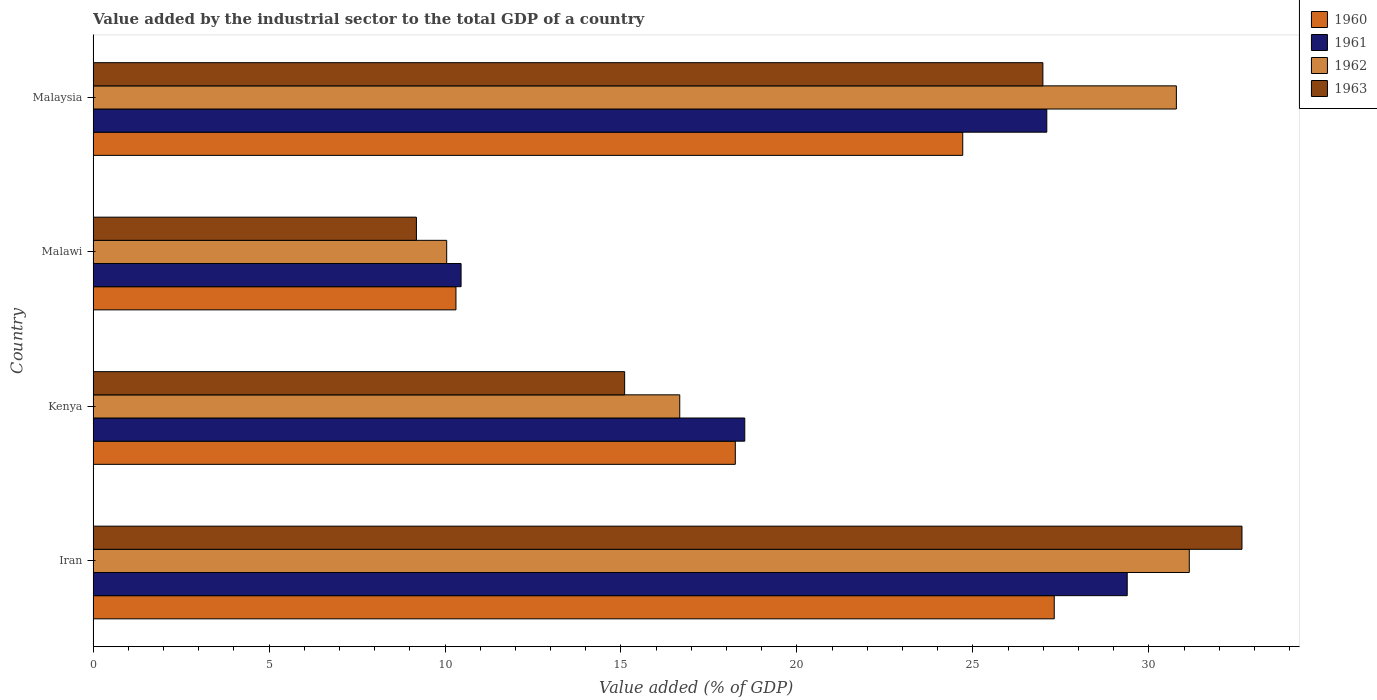How many groups of bars are there?
Provide a short and direct response. 4. Are the number of bars per tick equal to the number of legend labels?
Your response must be concise. Yes. How many bars are there on the 2nd tick from the top?
Give a very brief answer. 4. How many bars are there on the 3rd tick from the bottom?
Ensure brevity in your answer.  4. What is the label of the 2nd group of bars from the top?
Keep it short and to the point. Malawi. What is the value added by the industrial sector to the total GDP in 1963 in Kenya?
Offer a very short reply. 15.1. Across all countries, what is the maximum value added by the industrial sector to the total GDP in 1961?
Keep it short and to the point. 29.38. Across all countries, what is the minimum value added by the industrial sector to the total GDP in 1960?
Make the answer very short. 10.31. In which country was the value added by the industrial sector to the total GDP in 1961 maximum?
Your answer should be compact. Iran. In which country was the value added by the industrial sector to the total GDP in 1961 minimum?
Offer a very short reply. Malawi. What is the total value added by the industrial sector to the total GDP in 1962 in the graph?
Your response must be concise. 88.65. What is the difference between the value added by the industrial sector to the total GDP in 1961 in Iran and that in Malaysia?
Your answer should be very brief. 2.29. What is the difference between the value added by the industrial sector to the total GDP in 1961 in Malaysia and the value added by the industrial sector to the total GDP in 1960 in Malawi?
Offer a terse response. 16.79. What is the average value added by the industrial sector to the total GDP in 1962 per country?
Keep it short and to the point. 22.16. What is the difference between the value added by the industrial sector to the total GDP in 1961 and value added by the industrial sector to the total GDP in 1962 in Kenya?
Give a very brief answer. 1.85. What is the ratio of the value added by the industrial sector to the total GDP in 1963 in Malawi to that in Malaysia?
Offer a terse response. 0.34. Is the value added by the industrial sector to the total GDP in 1962 in Iran less than that in Malawi?
Give a very brief answer. No. Is the difference between the value added by the industrial sector to the total GDP in 1961 in Iran and Kenya greater than the difference between the value added by the industrial sector to the total GDP in 1962 in Iran and Kenya?
Provide a short and direct response. No. What is the difference between the highest and the second highest value added by the industrial sector to the total GDP in 1960?
Provide a short and direct response. 2.6. What is the difference between the highest and the lowest value added by the industrial sector to the total GDP in 1963?
Provide a succinct answer. 23.46. Is the sum of the value added by the industrial sector to the total GDP in 1961 in Iran and Malawi greater than the maximum value added by the industrial sector to the total GDP in 1963 across all countries?
Provide a short and direct response. Yes. What does the 2nd bar from the top in Kenya represents?
Your answer should be very brief. 1962. What does the 2nd bar from the bottom in Malawi represents?
Give a very brief answer. 1961. Is it the case that in every country, the sum of the value added by the industrial sector to the total GDP in 1961 and value added by the industrial sector to the total GDP in 1963 is greater than the value added by the industrial sector to the total GDP in 1960?
Offer a very short reply. Yes. How many bars are there?
Ensure brevity in your answer.  16. Are all the bars in the graph horizontal?
Provide a succinct answer. Yes. How many countries are there in the graph?
Provide a succinct answer. 4. What is the difference between two consecutive major ticks on the X-axis?
Ensure brevity in your answer.  5. Are the values on the major ticks of X-axis written in scientific E-notation?
Make the answer very short. No. Where does the legend appear in the graph?
Your answer should be compact. Top right. What is the title of the graph?
Make the answer very short. Value added by the industrial sector to the total GDP of a country. Does "2008" appear as one of the legend labels in the graph?
Make the answer very short. No. What is the label or title of the X-axis?
Provide a succinct answer. Value added (% of GDP). What is the label or title of the Y-axis?
Offer a terse response. Country. What is the Value added (% of GDP) of 1960 in Iran?
Provide a succinct answer. 27.31. What is the Value added (% of GDP) in 1961 in Iran?
Give a very brief answer. 29.38. What is the Value added (% of GDP) in 1962 in Iran?
Make the answer very short. 31.15. What is the Value added (% of GDP) of 1963 in Iran?
Offer a terse response. 32.65. What is the Value added (% of GDP) of 1960 in Kenya?
Provide a succinct answer. 18.25. What is the Value added (% of GDP) of 1961 in Kenya?
Provide a short and direct response. 18.52. What is the Value added (% of GDP) in 1962 in Kenya?
Your answer should be very brief. 16.67. What is the Value added (% of GDP) in 1963 in Kenya?
Your answer should be very brief. 15.1. What is the Value added (% of GDP) of 1960 in Malawi?
Ensure brevity in your answer.  10.31. What is the Value added (% of GDP) of 1961 in Malawi?
Make the answer very short. 10.46. What is the Value added (% of GDP) of 1962 in Malawi?
Provide a short and direct response. 10.05. What is the Value added (% of GDP) of 1963 in Malawi?
Provide a short and direct response. 9.19. What is the Value added (% of GDP) in 1960 in Malaysia?
Your answer should be very brief. 24.71. What is the Value added (% of GDP) of 1961 in Malaysia?
Your response must be concise. 27.1. What is the Value added (% of GDP) in 1962 in Malaysia?
Ensure brevity in your answer.  30.78. What is the Value added (% of GDP) of 1963 in Malaysia?
Your answer should be compact. 26.99. Across all countries, what is the maximum Value added (% of GDP) of 1960?
Your answer should be compact. 27.31. Across all countries, what is the maximum Value added (% of GDP) of 1961?
Ensure brevity in your answer.  29.38. Across all countries, what is the maximum Value added (% of GDP) of 1962?
Offer a terse response. 31.15. Across all countries, what is the maximum Value added (% of GDP) in 1963?
Make the answer very short. 32.65. Across all countries, what is the minimum Value added (% of GDP) in 1960?
Give a very brief answer. 10.31. Across all countries, what is the minimum Value added (% of GDP) of 1961?
Offer a very short reply. 10.46. Across all countries, what is the minimum Value added (% of GDP) in 1962?
Ensure brevity in your answer.  10.05. Across all countries, what is the minimum Value added (% of GDP) of 1963?
Your answer should be very brief. 9.19. What is the total Value added (% of GDP) in 1960 in the graph?
Your response must be concise. 80.58. What is the total Value added (% of GDP) of 1961 in the graph?
Your answer should be compact. 85.46. What is the total Value added (% of GDP) of 1962 in the graph?
Provide a succinct answer. 88.65. What is the total Value added (% of GDP) of 1963 in the graph?
Offer a very short reply. 83.93. What is the difference between the Value added (% of GDP) in 1960 in Iran and that in Kenya?
Make the answer very short. 9.06. What is the difference between the Value added (% of GDP) in 1961 in Iran and that in Kenya?
Keep it short and to the point. 10.87. What is the difference between the Value added (% of GDP) of 1962 in Iran and that in Kenya?
Provide a succinct answer. 14.48. What is the difference between the Value added (% of GDP) of 1963 in Iran and that in Kenya?
Provide a succinct answer. 17.54. What is the difference between the Value added (% of GDP) of 1960 in Iran and that in Malawi?
Offer a very short reply. 17. What is the difference between the Value added (% of GDP) of 1961 in Iran and that in Malawi?
Ensure brevity in your answer.  18.93. What is the difference between the Value added (% of GDP) of 1962 in Iran and that in Malawi?
Ensure brevity in your answer.  21.1. What is the difference between the Value added (% of GDP) in 1963 in Iran and that in Malawi?
Provide a short and direct response. 23.46. What is the difference between the Value added (% of GDP) of 1960 in Iran and that in Malaysia?
Your response must be concise. 2.6. What is the difference between the Value added (% of GDP) of 1961 in Iran and that in Malaysia?
Provide a short and direct response. 2.29. What is the difference between the Value added (% of GDP) in 1962 in Iran and that in Malaysia?
Your response must be concise. 0.37. What is the difference between the Value added (% of GDP) in 1963 in Iran and that in Malaysia?
Your answer should be very brief. 5.66. What is the difference between the Value added (% of GDP) of 1960 in Kenya and that in Malawi?
Ensure brevity in your answer.  7.94. What is the difference between the Value added (% of GDP) in 1961 in Kenya and that in Malawi?
Give a very brief answer. 8.06. What is the difference between the Value added (% of GDP) in 1962 in Kenya and that in Malawi?
Your answer should be compact. 6.62. What is the difference between the Value added (% of GDP) in 1963 in Kenya and that in Malawi?
Offer a very short reply. 5.92. What is the difference between the Value added (% of GDP) in 1960 in Kenya and that in Malaysia?
Give a very brief answer. -6.46. What is the difference between the Value added (% of GDP) in 1961 in Kenya and that in Malaysia?
Offer a very short reply. -8.58. What is the difference between the Value added (% of GDP) of 1962 in Kenya and that in Malaysia?
Ensure brevity in your answer.  -14.11. What is the difference between the Value added (% of GDP) in 1963 in Kenya and that in Malaysia?
Provide a short and direct response. -11.88. What is the difference between the Value added (% of GDP) in 1960 in Malawi and that in Malaysia?
Your answer should be compact. -14.4. What is the difference between the Value added (% of GDP) in 1961 in Malawi and that in Malaysia?
Your answer should be compact. -16.64. What is the difference between the Value added (% of GDP) in 1962 in Malawi and that in Malaysia?
Provide a succinct answer. -20.73. What is the difference between the Value added (% of GDP) in 1963 in Malawi and that in Malaysia?
Your answer should be very brief. -17.8. What is the difference between the Value added (% of GDP) in 1960 in Iran and the Value added (% of GDP) in 1961 in Kenya?
Make the answer very short. 8.79. What is the difference between the Value added (% of GDP) of 1960 in Iran and the Value added (% of GDP) of 1962 in Kenya?
Provide a succinct answer. 10.64. What is the difference between the Value added (% of GDP) of 1960 in Iran and the Value added (% of GDP) of 1963 in Kenya?
Offer a very short reply. 12.21. What is the difference between the Value added (% of GDP) in 1961 in Iran and the Value added (% of GDP) in 1962 in Kenya?
Your response must be concise. 12.71. What is the difference between the Value added (% of GDP) of 1961 in Iran and the Value added (% of GDP) of 1963 in Kenya?
Ensure brevity in your answer.  14.28. What is the difference between the Value added (% of GDP) in 1962 in Iran and the Value added (% of GDP) in 1963 in Kenya?
Provide a short and direct response. 16.04. What is the difference between the Value added (% of GDP) in 1960 in Iran and the Value added (% of GDP) in 1961 in Malawi?
Provide a short and direct response. 16.86. What is the difference between the Value added (% of GDP) of 1960 in Iran and the Value added (% of GDP) of 1962 in Malawi?
Your response must be concise. 17.26. What is the difference between the Value added (% of GDP) in 1960 in Iran and the Value added (% of GDP) in 1963 in Malawi?
Your answer should be very brief. 18.12. What is the difference between the Value added (% of GDP) in 1961 in Iran and the Value added (% of GDP) in 1962 in Malawi?
Offer a terse response. 19.34. What is the difference between the Value added (% of GDP) of 1961 in Iran and the Value added (% of GDP) of 1963 in Malawi?
Ensure brevity in your answer.  20.2. What is the difference between the Value added (% of GDP) in 1962 in Iran and the Value added (% of GDP) in 1963 in Malawi?
Offer a very short reply. 21.96. What is the difference between the Value added (% of GDP) of 1960 in Iran and the Value added (% of GDP) of 1961 in Malaysia?
Ensure brevity in your answer.  0.21. What is the difference between the Value added (% of GDP) in 1960 in Iran and the Value added (% of GDP) in 1962 in Malaysia?
Keep it short and to the point. -3.47. What is the difference between the Value added (% of GDP) in 1960 in Iran and the Value added (% of GDP) in 1963 in Malaysia?
Make the answer very short. 0.32. What is the difference between the Value added (% of GDP) of 1961 in Iran and the Value added (% of GDP) of 1962 in Malaysia?
Make the answer very short. -1.4. What is the difference between the Value added (% of GDP) in 1961 in Iran and the Value added (% of GDP) in 1963 in Malaysia?
Provide a short and direct response. 2.4. What is the difference between the Value added (% of GDP) of 1962 in Iran and the Value added (% of GDP) of 1963 in Malaysia?
Your answer should be very brief. 4.16. What is the difference between the Value added (% of GDP) of 1960 in Kenya and the Value added (% of GDP) of 1961 in Malawi?
Offer a very short reply. 7.79. What is the difference between the Value added (% of GDP) of 1960 in Kenya and the Value added (% of GDP) of 1962 in Malawi?
Offer a terse response. 8.2. What is the difference between the Value added (% of GDP) of 1960 in Kenya and the Value added (% of GDP) of 1963 in Malawi?
Make the answer very short. 9.06. What is the difference between the Value added (% of GDP) in 1961 in Kenya and the Value added (% of GDP) in 1962 in Malawi?
Your answer should be compact. 8.47. What is the difference between the Value added (% of GDP) of 1961 in Kenya and the Value added (% of GDP) of 1963 in Malawi?
Make the answer very short. 9.33. What is the difference between the Value added (% of GDP) in 1962 in Kenya and the Value added (% of GDP) in 1963 in Malawi?
Your answer should be compact. 7.48. What is the difference between the Value added (% of GDP) of 1960 in Kenya and the Value added (% of GDP) of 1961 in Malaysia?
Offer a terse response. -8.85. What is the difference between the Value added (% of GDP) in 1960 in Kenya and the Value added (% of GDP) in 1962 in Malaysia?
Make the answer very short. -12.53. What is the difference between the Value added (% of GDP) in 1960 in Kenya and the Value added (% of GDP) in 1963 in Malaysia?
Give a very brief answer. -8.74. What is the difference between the Value added (% of GDP) in 1961 in Kenya and the Value added (% of GDP) in 1962 in Malaysia?
Make the answer very short. -12.26. What is the difference between the Value added (% of GDP) in 1961 in Kenya and the Value added (% of GDP) in 1963 in Malaysia?
Your answer should be very brief. -8.47. What is the difference between the Value added (% of GDP) in 1962 in Kenya and the Value added (% of GDP) in 1963 in Malaysia?
Give a very brief answer. -10.32. What is the difference between the Value added (% of GDP) of 1960 in Malawi and the Value added (% of GDP) of 1961 in Malaysia?
Provide a succinct answer. -16.79. What is the difference between the Value added (% of GDP) in 1960 in Malawi and the Value added (% of GDP) in 1962 in Malaysia?
Give a very brief answer. -20.47. What is the difference between the Value added (% of GDP) in 1960 in Malawi and the Value added (% of GDP) in 1963 in Malaysia?
Your response must be concise. -16.68. What is the difference between the Value added (% of GDP) in 1961 in Malawi and the Value added (% of GDP) in 1962 in Malaysia?
Provide a succinct answer. -20.33. What is the difference between the Value added (% of GDP) of 1961 in Malawi and the Value added (% of GDP) of 1963 in Malaysia?
Provide a short and direct response. -16.53. What is the difference between the Value added (% of GDP) of 1962 in Malawi and the Value added (% of GDP) of 1963 in Malaysia?
Your answer should be very brief. -16.94. What is the average Value added (% of GDP) of 1960 per country?
Your response must be concise. 20.15. What is the average Value added (% of GDP) of 1961 per country?
Provide a succinct answer. 21.36. What is the average Value added (% of GDP) of 1962 per country?
Ensure brevity in your answer.  22.16. What is the average Value added (% of GDP) in 1963 per country?
Offer a very short reply. 20.98. What is the difference between the Value added (% of GDP) in 1960 and Value added (% of GDP) in 1961 in Iran?
Ensure brevity in your answer.  -2.07. What is the difference between the Value added (% of GDP) in 1960 and Value added (% of GDP) in 1962 in Iran?
Offer a terse response. -3.84. What is the difference between the Value added (% of GDP) in 1960 and Value added (% of GDP) in 1963 in Iran?
Your response must be concise. -5.33. What is the difference between the Value added (% of GDP) in 1961 and Value added (% of GDP) in 1962 in Iran?
Keep it short and to the point. -1.76. What is the difference between the Value added (% of GDP) in 1961 and Value added (% of GDP) in 1963 in Iran?
Make the answer very short. -3.26. What is the difference between the Value added (% of GDP) in 1962 and Value added (% of GDP) in 1963 in Iran?
Offer a very short reply. -1.5. What is the difference between the Value added (% of GDP) of 1960 and Value added (% of GDP) of 1961 in Kenya?
Your answer should be compact. -0.27. What is the difference between the Value added (% of GDP) in 1960 and Value added (% of GDP) in 1962 in Kenya?
Provide a short and direct response. 1.58. What is the difference between the Value added (% of GDP) in 1960 and Value added (% of GDP) in 1963 in Kenya?
Provide a short and direct response. 3.14. What is the difference between the Value added (% of GDP) in 1961 and Value added (% of GDP) in 1962 in Kenya?
Your answer should be compact. 1.85. What is the difference between the Value added (% of GDP) in 1961 and Value added (% of GDP) in 1963 in Kenya?
Offer a terse response. 3.41. What is the difference between the Value added (% of GDP) of 1962 and Value added (% of GDP) of 1963 in Kenya?
Keep it short and to the point. 1.57. What is the difference between the Value added (% of GDP) in 1960 and Value added (% of GDP) in 1961 in Malawi?
Make the answer very short. -0.15. What is the difference between the Value added (% of GDP) of 1960 and Value added (% of GDP) of 1962 in Malawi?
Make the answer very short. 0.26. What is the difference between the Value added (% of GDP) in 1960 and Value added (% of GDP) in 1963 in Malawi?
Provide a succinct answer. 1.12. What is the difference between the Value added (% of GDP) of 1961 and Value added (% of GDP) of 1962 in Malawi?
Make the answer very short. 0.41. What is the difference between the Value added (% of GDP) of 1961 and Value added (% of GDP) of 1963 in Malawi?
Provide a succinct answer. 1.27. What is the difference between the Value added (% of GDP) of 1962 and Value added (% of GDP) of 1963 in Malawi?
Provide a short and direct response. 0.86. What is the difference between the Value added (% of GDP) of 1960 and Value added (% of GDP) of 1961 in Malaysia?
Offer a very short reply. -2.39. What is the difference between the Value added (% of GDP) in 1960 and Value added (% of GDP) in 1962 in Malaysia?
Make the answer very short. -6.07. What is the difference between the Value added (% of GDP) of 1960 and Value added (% of GDP) of 1963 in Malaysia?
Your answer should be very brief. -2.28. What is the difference between the Value added (% of GDP) of 1961 and Value added (% of GDP) of 1962 in Malaysia?
Offer a terse response. -3.68. What is the difference between the Value added (% of GDP) of 1961 and Value added (% of GDP) of 1963 in Malaysia?
Provide a short and direct response. 0.11. What is the difference between the Value added (% of GDP) of 1962 and Value added (% of GDP) of 1963 in Malaysia?
Provide a succinct answer. 3.79. What is the ratio of the Value added (% of GDP) in 1960 in Iran to that in Kenya?
Your answer should be compact. 1.5. What is the ratio of the Value added (% of GDP) in 1961 in Iran to that in Kenya?
Offer a terse response. 1.59. What is the ratio of the Value added (% of GDP) in 1962 in Iran to that in Kenya?
Offer a very short reply. 1.87. What is the ratio of the Value added (% of GDP) of 1963 in Iran to that in Kenya?
Your answer should be very brief. 2.16. What is the ratio of the Value added (% of GDP) of 1960 in Iran to that in Malawi?
Offer a very short reply. 2.65. What is the ratio of the Value added (% of GDP) of 1961 in Iran to that in Malawi?
Offer a terse response. 2.81. What is the ratio of the Value added (% of GDP) in 1962 in Iran to that in Malawi?
Offer a very short reply. 3.1. What is the ratio of the Value added (% of GDP) of 1963 in Iran to that in Malawi?
Offer a terse response. 3.55. What is the ratio of the Value added (% of GDP) in 1960 in Iran to that in Malaysia?
Ensure brevity in your answer.  1.11. What is the ratio of the Value added (% of GDP) in 1961 in Iran to that in Malaysia?
Your answer should be very brief. 1.08. What is the ratio of the Value added (% of GDP) in 1962 in Iran to that in Malaysia?
Your answer should be compact. 1.01. What is the ratio of the Value added (% of GDP) in 1963 in Iran to that in Malaysia?
Keep it short and to the point. 1.21. What is the ratio of the Value added (% of GDP) in 1960 in Kenya to that in Malawi?
Your answer should be compact. 1.77. What is the ratio of the Value added (% of GDP) in 1961 in Kenya to that in Malawi?
Your response must be concise. 1.77. What is the ratio of the Value added (% of GDP) in 1962 in Kenya to that in Malawi?
Provide a succinct answer. 1.66. What is the ratio of the Value added (% of GDP) of 1963 in Kenya to that in Malawi?
Your answer should be compact. 1.64. What is the ratio of the Value added (% of GDP) of 1960 in Kenya to that in Malaysia?
Provide a succinct answer. 0.74. What is the ratio of the Value added (% of GDP) of 1961 in Kenya to that in Malaysia?
Ensure brevity in your answer.  0.68. What is the ratio of the Value added (% of GDP) of 1962 in Kenya to that in Malaysia?
Provide a succinct answer. 0.54. What is the ratio of the Value added (% of GDP) in 1963 in Kenya to that in Malaysia?
Offer a terse response. 0.56. What is the ratio of the Value added (% of GDP) in 1960 in Malawi to that in Malaysia?
Give a very brief answer. 0.42. What is the ratio of the Value added (% of GDP) in 1961 in Malawi to that in Malaysia?
Make the answer very short. 0.39. What is the ratio of the Value added (% of GDP) of 1962 in Malawi to that in Malaysia?
Your answer should be compact. 0.33. What is the ratio of the Value added (% of GDP) of 1963 in Malawi to that in Malaysia?
Give a very brief answer. 0.34. What is the difference between the highest and the second highest Value added (% of GDP) of 1960?
Ensure brevity in your answer.  2.6. What is the difference between the highest and the second highest Value added (% of GDP) of 1961?
Offer a very short reply. 2.29. What is the difference between the highest and the second highest Value added (% of GDP) of 1962?
Your answer should be very brief. 0.37. What is the difference between the highest and the second highest Value added (% of GDP) in 1963?
Your answer should be very brief. 5.66. What is the difference between the highest and the lowest Value added (% of GDP) of 1960?
Ensure brevity in your answer.  17. What is the difference between the highest and the lowest Value added (% of GDP) in 1961?
Provide a short and direct response. 18.93. What is the difference between the highest and the lowest Value added (% of GDP) in 1962?
Offer a terse response. 21.1. What is the difference between the highest and the lowest Value added (% of GDP) in 1963?
Offer a very short reply. 23.46. 